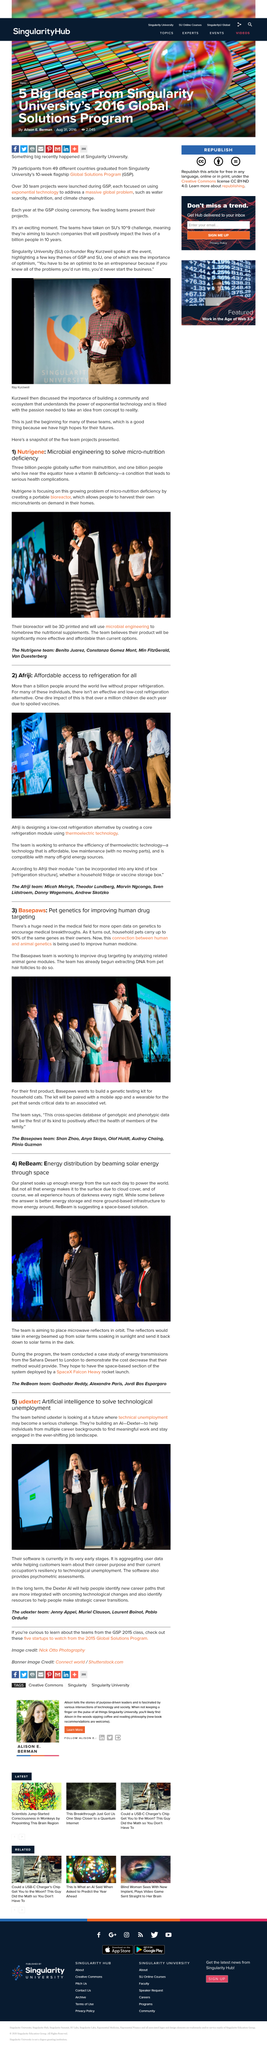Give some essential details in this illustration. It is reported that the entity plans to use the SpaceX Falcon Heavy rocket for their mission. Dexter is a type of artificial intelligence. Basepaws' first-generation genetic testing kit will be for cats, according to the company's announcement. The team behind the UDEXTER artificial intelligence aims to tackle the challenge of technical unemployment by providing advanced tools and resources to increase productivity and efficiency, ultimately benefiting both businesses and workers. Over 30 team projects were launched. 